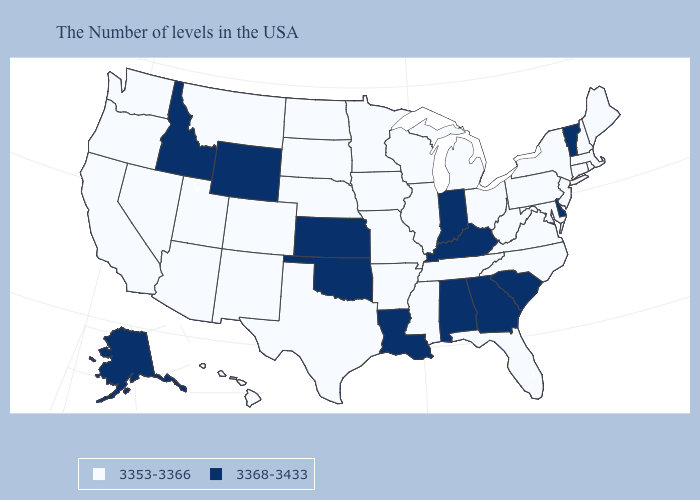Which states hav the highest value in the West?
Answer briefly. Wyoming, Idaho, Alaska. Does the map have missing data?
Write a very short answer. No. Name the states that have a value in the range 3353-3366?
Write a very short answer. Maine, Massachusetts, Rhode Island, New Hampshire, Connecticut, New York, New Jersey, Maryland, Pennsylvania, Virginia, North Carolina, West Virginia, Ohio, Florida, Michigan, Tennessee, Wisconsin, Illinois, Mississippi, Missouri, Arkansas, Minnesota, Iowa, Nebraska, Texas, South Dakota, North Dakota, Colorado, New Mexico, Utah, Montana, Arizona, Nevada, California, Washington, Oregon, Hawaii. Which states have the lowest value in the USA?
Be succinct. Maine, Massachusetts, Rhode Island, New Hampshire, Connecticut, New York, New Jersey, Maryland, Pennsylvania, Virginia, North Carolina, West Virginia, Ohio, Florida, Michigan, Tennessee, Wisconsin, Illinois, Mississippi, Missouri, Arkansas, Minnesota, Iowa, Nebraska, Texas, South Dakota, North Dakota, Colorado, New Mexico, Utah, Montana, Arizona, Nevada, California, Washington, Oregon, Hawaii. What is the value of Washington?
Keep it brief. 3353-3366. What is the lowest value in states that border Pennsylvania?
Short answer required. 3353-3366. Name the states that have a value in the range 3353-3366?
Give a very brief answer. Maine, Massachusetts, Rhode Island, New Hampshire, Connecticut, New York, New Jersey, Maryland, Pennsylvania, Virginia, North Carolina, West Virginia, Ohio, Florida, Michigan, Tennessee, Wisconsin, Illinois, Mississippi, Missouri, Arkansas, Minnesota, Iowa, Nebraska, Texas, South Dakota, North Dakota, Colorado, New Mexico, Utah, Montana, Arizona, Nevada, California, Washington, Oregon, Hawaii. What is the value of Washington?
Be succinct. 3353-3366. Name the states that have a value in the range 3368-3433?
Short answer required. Vermont, Delaware, South Carolina, Georgia, Kentucky, Indiana, Alabama, Louisiana, Kansas, Oklahoma, Wyoming, Idaho, Alaska. Which states have the lowest value in the USA?
Write a very short answer. Maine, Massachusetts, Rhode Island, New Hampshire, Connecticut, New York, New Jersey, Maryland, Pennsylvania, Virginia, North Carolina, West Virginia, Ohio, Florida, Michigan, Tennessee, Wisconsin, Illinois, Mississippi, Missouri, Arkansas, Minnesota, Iowa, Nebraska, Texas, South Dakota, North Dakota, Colorado, New Mexico, Utah, Montana, Arizona, Nevada, California, Washington, Oregon, Hawaii. Does California have the highest value in the USA?
Concise answer only. No. What is the value of Texas?
Be succinct. 3353-3366. Among the states that border South Carolina , does Georgia have the highest value?
Quick response, please. Yes. What is the value of Georgia?
Keep it brief. 3368-3433. What is the highest value in the Northeast ?
Short answer required. 3368-3433. 